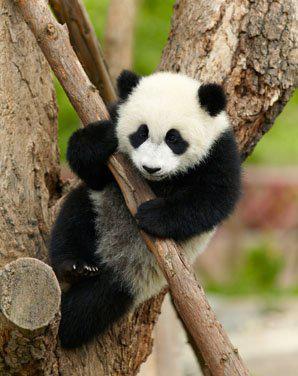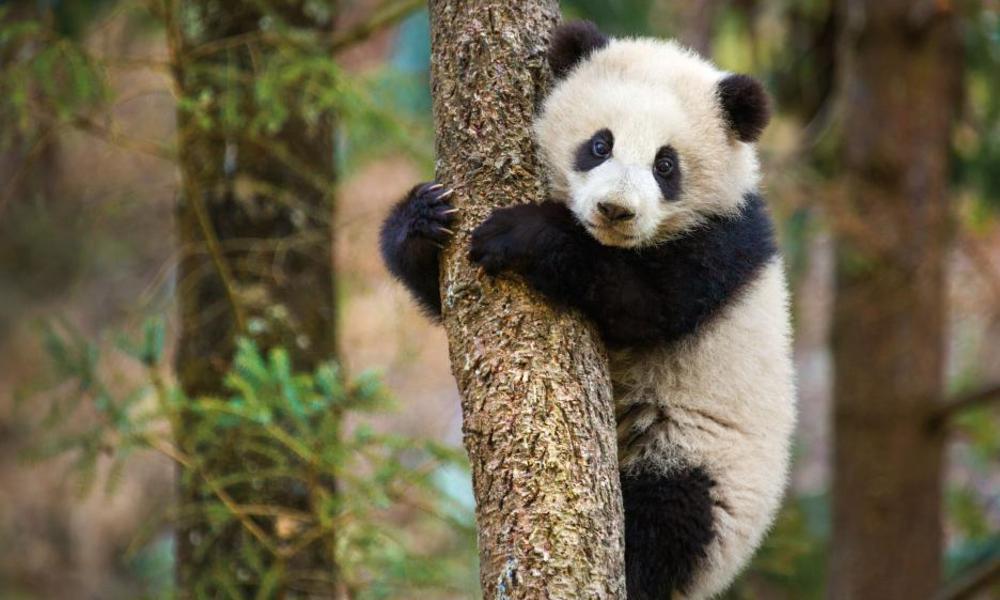The first image is the image on the left, the second image is the image on the right. Evaluate the accuracy of this statement regarding the images: "There are two pandas climbing a branch.". Is it true? Answer yes or no. Yes. The first image is the image on the left, the second image is the image on the right. Given the left and right images, does the statement "There are no more than three panda bears." hold true? Answer yes or no. Yes. 